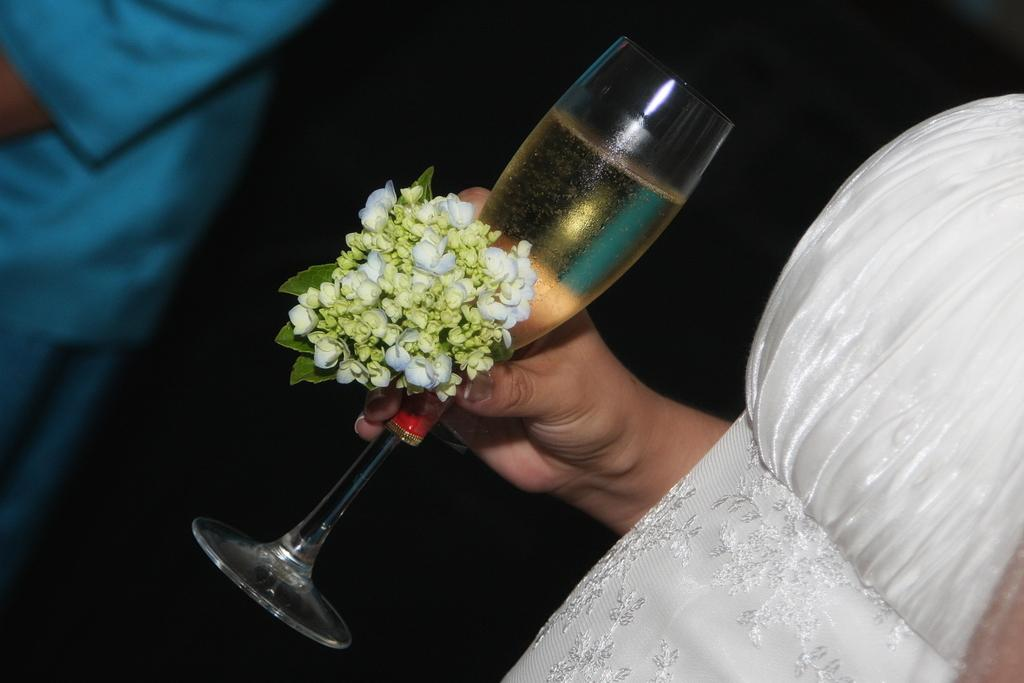Who is the main subject in the image? There is a woman in the image. What is the woman holding in her hand? The woman is holding a glass of wine and flowers. Can you describe the person in front of the woman? There is another person in front of the woman, but their specific features or actions are not mentioned in the facts. What type of rock is the woman using to hold the flowers in the image? There is no rock present in the image; the woman is holding the flowers with her hand. How many thumbs does the woman have in the image? The facts do not mention the number of thumbs the woman has, but typically humans have two thumbs. --- Facts: 1. There is a car in the image. 2. The car is parked on the street. 3. The car is red. 4. There are trees in the background of the image. 5. The sky is visible in the image. Absurd Topics: parrot, sandcastle, volcano Conversation: What is the main subject in the image? There is a car in the image. Where is the car located in the image? The car is parked on the street. What color is the car? The car is red. What can be seen in the background of the image? There are trees in the background of the image. What is visible at the top of the image? The sky is visible in the image. Reasoning: Let's think step by step in order to produce the conversation. We start by identifying the main subject in the image, which is the car. Then, we describe the car's location, color, and the background elements visible in the image. Finally, we mention the sky's visibility at the top of the image. Absurd Question/Answer: Can you tell me how many parrots are sitting on the car in the image? There are no parrots present in the image; it only features a red car parked on the street. Is there a volcano erupting in the background of the image? There is no volcano present in the image; it only features trees in the background. 